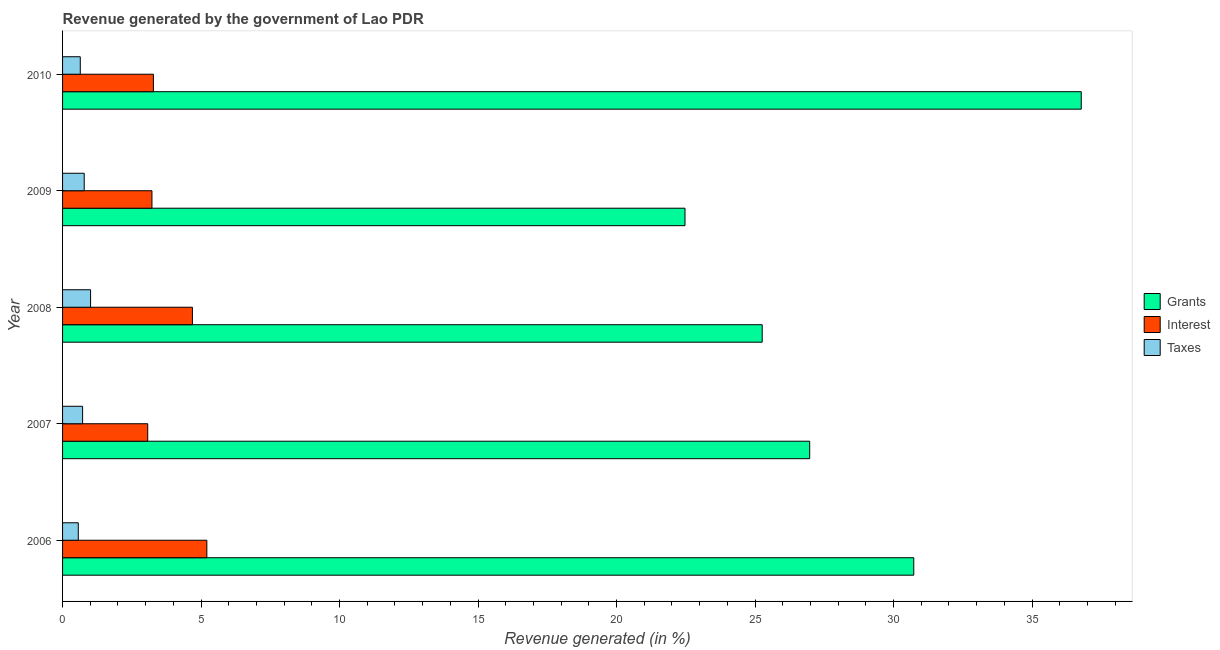How many different coloured bars are there?
Your answer should be very brief. 3. How many bars are there on the 2nd tick from the bottom?
Offer a terse response. 3. What is the percentage of revenue generated by taxes in 2008?
Ensure brevity in your answer.  1.01. Across all years, what is the maximum percentage of revenue generated by interest?
Offer a very short reply. 5.21. Across all years, what is the minimum percentage of revenue generated by interest?
Make the answer very short. 3.07. In which year was the percentage of revenue generated by interest maximum?
Ensure brevity in your answer.  2006. What is the total percentage of revenue generated by interest in the graph?
Offer a terse response. 19.48. What is the difference between the percentage of revenue generated by grants in 2009 and that in 2010?
Provide a succinct answer. -14.3. What is the difference between the percentage of revenue generated by interest in 2010 and the percentage of revenue generated by grants in 2007?
Offer a terse response. -23.69. What is the average percentage of revenue generated by grants per year?
Ensure brevity in your answer.  28.44. In the year 2009, what is the difference between the percentage of revenue generated by taxes and percentage of revenue generated by interest?
Your response must be concise. -2.44. What is the ratio of the percentage of revenue generated by grants in 2008 to that in 2010?
Ensure brevity in your answer.  0.69. Is the difference between the percentage of revenue generated by interest in 2007 and 2009 greater than the difference between the percentage of revenue generated by grants in 2007 and 2009?
Offer a terse response. No. What is the difference between the highest and the second highest percentage of revenue generated by interest?
Offer a very short reply. 0.52. What is the difference between the highest and the lowest percentage of revenue generated by taxes?
Your response must be concise. 0.44. Is the sum of the percentage of revenue generated by interest in 2006 and 2007 greater than the maximum percentage of revenue generated by grants across all years?
Provide a succinct answer. No. What does the 3rd bar from the top in 2006 represents?
Provide a short and direct response. Grants. What does the 2nd bar from the bottom in 2009 represents?
Offer a very short reply. Interest. Is it the case that in every year, the sum of the percentage of revenue generated by grants and percentage of revenue generated by interest is greater than the percentage of revenue generated by taxes?
Your answer should be compact. Yes. Are all the bars in the graph horizontal?
Give a very brief answer. Yes. How many years are there in the graph?
Offer a very short reply. 5. Are the values on the major ticks of X-axis written in scientific E-notation?
Make the answer very short. No. How are the legend labels stacked?
Give a very brief answer. Vertical. What is the title of the graph?
Make the answer very short. Revenue generated by the government of Lao PDR. Does "Primary education" appear as one of the legend labels in the graph?
Your answer should be very brief. No. What is the label or title of the X-axis?
Your answer should be compact. Revenue generated (in %). What is the Revenue generated (in %) of Grants in 2006?
Your answer should be compact. 30.73. What is the Revenue generated (in %) in Interest in 2006?
Your answer should be very brief. 5.21. What is the Revenue generated (in %) in Taxes in 2006?
Ensure brevity in your answer.  0.57. What is the Revenue generated (in %) in Grants in 2007?
Offer a very short reply. 26.97. What is the Revenue generated (in %) in Interest in 2007?
Provide a succinct answer. 3.07. What is the Revenue generated (in %) in Taxes in 2007?
Keep it short and to the point. 0.72. What is the Revenue generated (in %) in Grants in 2008?
Your answer should be compact. 25.26. What is the Revenue generated (in %) in Interest in 2008?
Your answer should be very brief. 4.69. What is the Revenue generated (in %) of Taxes in 2008?
Provide a short and direct response. 1.01. What is the Revenue generated (in %) of Grants in 2009?
Offer a terse response. 22.47. What is the Revenue generated (in %) in Interest in 2009?
Offer a terse response. 3.23. What is the Revenue generated (in %) of Taxes in 2009?
Your answer should be very brief. 0.78. What is the Revenue generated (in %) in Grants in 2010?
Your answer should be compact. 36.78. What is the Revenue generated (in %) of Interest in 2010?
Offer a terse response. 3.28. What is the Revenue generated (in %) in Taxes in 2010?
Make the answer very short. 0.64. Across all years, what is the maximum Revenue generated (in %) in Grants?
Ensure brevity in your answer.  36.78. Across all years, what is the maximum Revenue generated (in %) of Interest?
Provide a succinct answer. 5.21. Across all years, what is the maximum Revenue generated (in %) in Taxes?
Your answer should be very brief. 1.01. Across all years, what is the minimum Revenue generated (in %) in Grants?
Your answer should be compact. 22.47. Across all years, what is the minimum Revenue generated (in %) of Interest?
Offer a terse response. 3.07. Across all years, what is the minimum Revenue generated (in %) of Taxes?
Keep it short and to the point. 0.57. What is the total Revenue generated (in %) in Grants in the graph?
Ensure brevity in your answer.  142.21. What is the total Revenue generated (in %) in Interest in the graph?
Ensure brevity in your answer.  19.48. What is the total Revenue generated (in %) of Taxes in the graph?
Keep it short and to the point. 3.72. What is the difference between the Revenue generated (in %) of Grants in 2006 and that in 2007?
Your answer should be compact. 3.76. What is the difference between the Revenue generated (in %) in Interest in 2006 and that in 2007?
Make the answer very short. 2.13. What is the difference between the Revenue generated (in %) in Taxes in 2006 and that in 2007?
Offer a very short reply. -0.16. What is the difference between the Revenue generated (in %) in Grants in 2006 and that in 2008?
Your answer should be very brief. 5.47. What is the difference between the Revenue generated (in %) of Interest in 2006 and that in 2008?
Your answer should be compact. 0.52. What is the difference between the Revenue generated (in %) in Taxes in 2006 and that in 2008?
Offer a terse response. -0.44. What is the difference between the Revenue generated (in %) in Grants in 2006 and that in 2009?
Provide a short and direct response. 8.26. What is the difference between the Revenue generated (in %) of Interest in 2006 and that in 2009?
Keep it short and to the point. 1.98. What is the difference between the Revenue generated (in %) of Taxes in 2006 and that in 2009?
Your response must be concise. -0.21. What is the difference between the Revenue generated (in %) in Grants in 2006 and that in 2010?
Offer a terse response. -6.05. What is the difference between the Revenue generated (in %) of Interest in 2006 and that in 2010?
Offer a terse response. 1.93. What is the difference between the Revenue generated (in %) of Taxes in 2006 and that in 2010?
Provide a short and direct response. -0.07. What is the difference between the Revenue generated (in %) in Grants in 2007 and that in 2008?
Give a very brief answer. 1.71. What is the difference between the Revenue generated (in %) of Interest in 2007 and that in 2008?
Your response must be concise. -1.61. What is the difference between the Revenue generated (in %) in Taxes in 2007 and that in 2008?
Your response must be concise. -0.29. What is the difference between the Revenue generated (in %) in Grants in 2007 and that in 2009?
Your answer should be very brief. 4.5. What is the difference between the Revenue generated (in %) of Interest in 2007 and that in 2009?
Provide a short and direct response. -0.15. What is the difference between the Revenue generated (in %) of Taxes in 2007 and that in 2009?
Give a very brief answer. -0.06. What is the difference between the Revenue generated (in %) of Grants in 2007 and that in 2010?
Ensure brevity in your answer.  -9.8. What is the difference between the Revenue generated (in %) in Interest in 2007 and that in 2010?
Offer a very short reply. -0.21. What is the difference between the Revenue generated (in %) of Taxes in 2007 and that in 2010?
Your answer should be very brief. 0.08. What is the difference between the Revenue generated (in %) of Grants in 2008 and that in 2009?
Ensure brevity in your answer.  2.79. What is the difference between the Revenue generated (in %) of Interest in 2008 and that in 2009?
Offer a very short reply. 1.46. What is the difference between the Revenue generated (in %) in Taxes in 2008 and that in 2009?
Provide a succinct answer. 0.23. What is the difference between the Revenue generated (in %) of Grants in 2008 and that in 2010?
Provide a short and direct response. -11.52. What is the difference between the Revenue generated (in %) of Interest in 2008 and that in 2010?
Provide a short and direct response. 1.41. What is the difference between the Revenue generated (in %) of Taxes in 2008 and that in 2010?
Your answer should be compact. 0.37. What is the difference between the Revenue generated (in %) of Grants in 2009 and that in 2010?
Provide a short and direct response. -14.31. What is the difference between the Revenue generated (in %) in Interest in 2009 and that in 2010?
Ensure brevity in your answer.  -0.05. What is the difference between the Revenue generated (in %) in Taxes in 2009 and that in 2010?
Provide a short and direct response. 0.14. What is the difference between the Revenue generated (in %) in Grants in 2006 and the Revenue generated (in %) in Interest in 2007?
Offer a very short reply. 27.66. What is the difference between the Revenue generated (in %) in Grants in 2006 and the Revenue generated (in %) in Taxes in 2007?
Provide a short and direct response. 30.01. What is the difference between the Revenue generated (in %) in Interest in 2006 and the Revenue generated (in %) in Taxes in 2007?
Keep it short and to the point. 4.49. What is the difference between the Revenue generated (in %) of Grants in 2006 and the Revenue generated (in %) of Interest in 2008?
Make the answer very short. 26.04. What is the difference between the Revenue generated (in %) of Grants in 2006 and the Revenue generated (in %) of Taxes in 2008?
Your answer should be very brief. 29.72. What is the difference between the Revenue generated (in %) in Interest in 2006 and the Revenue generated (in %) in Taxes in 2008?
Your response must be concise. 4.2. What is the difference between the Revenue generated (in %) of Grants in 2006 and the Revenue generated (in %) of Interest in 2009?
Offer a terse response. 27.5. What is the difference between the Revenue generated (in %) in Grants in 2006 and the Revenue generated (in %) in Taxes in 2009?
Give a very brief answer. 29.95. What is the difference between the Revenue generated (in %) in Interest in 2006 and the Revenue generated (in %) in Taxes in 2009?
Your answer should be compact. 4.43. What is the difference between the Revenue generated (in %) of Grants in 2006 and the Revenue generated (in %) of Interest in 2010?
Your answer should be compact. 27.45. What is the difference between the Revenue generated (in %) in Grants in 2006 and the Revenue generated (in %) in Taxes in 2010?
Ensure brevity in your answer.  30.09. What is the difference between the Revenue generated (in %) of Interest in 2006 and the Revenue generated (in %) of Taxes in 2010?
Your answer should be compact. 4.57. What is the difference between the Revenue generated (in %) of Grants in 2007 and the Revenue generated (in %) of Interest in 2008?
Ensure brevity in your answer.  22.28. What is the difference between the Revenue generated (in %) in Grants in 2007 and the Revenue generated (in %) in Taxes in 2008?
Your answer should be compact. 25.96. What is the difference between the Revenue generated (in %) of Interest in 2007 and the Revenue generated (in %) of Taxes in 2008?
Provide a short and direct response. 2.06. What is the difference between the Revenue generated (in %) in Grants in 2007 and the Revenue generated (in %) in Interest in 2009?
Your answer should be compact. 23.75. What is the difference between the Revenue generated (in %) of Grants in 2007 and the Revenue generated (in %) of Taxes in 2009?
Offer a very short reply. 26.19. What is the difference between the Revenue generated (in %) of Interest in 2007 and the Revenue generated (in %) of Taxes in 2009?
Ensure brevity in your answer.  2.29. What is the difference between the Revenue generated (in %) in Grants in 2007 and the Revenue generated (in %) in Interest in 2010?
Your response must be concise. 23.69. What is the difference between the Revenue generated (in %) of Grants in 2007 and the Revenue generated (in %) of Taxes in 2010?
Your answer should be very brief. 26.33. What is the difference between the Revenue generated (in %) of Interest in 2007 and the Revenue generated (in %) of Taxes in 2010?
Make the answer very short. 2.43. What is the difference between the Revenue generated (in %) of Grants in 2008 and the Revenue generated (in %) of Interest in 2009?
Your response must be concise. 22.03. What is the difference between the Revenue generated (in %) of Grants in 2008 and the Revenue generated (in %) of Taxes in 2009?
Your answer should be compact. 24.48. What is the difference between the Revenue generated (in %) in Interest in 2008 and the Revenue generated (in %) in Taxes in 2009?
Keep it short and to the point. 3.91. What is the difference between the Revenue generated (in %) of Grants in 2008 and the Revenue generated (in %) of Interest in 2010?
Your response must be concise. 21.98. What is the difference between the Revenue generated (in %) of Grants in 2008 and the Revenue generated (in %) of Taxes in 2010?
Provide a succinct answer. 24.62. What is the difference between the Revenue generated (in %) in Interest in 2008 and the Revenue generated (in %) in Taxes in 2010?
Give a very brief answer. 4.05. What is the difference between the Revenue generated (in %) of Grants in 2009 and the Revenue generated (in %) of Interest in 2010?
Make the answer very short. 19.19. What is the difference between the Revenue generated (in %) of Grants in 2009 and the Revenue generated (in %) of Taxes in 2010?
Ensure brevity in your answer.  21.83. What is the difference between the Revenue generated (in %) of Interest in 2009 and the Revenue generated (in %) of Taxes in 2010?
Your response must be concise. 2.59. What is the average Revenue generated (in %) in Grants per year?
Give a very brief answer. 28.44. What is the average Revenue generated (in %) of Interest per year?
Your answer should be very brief. 3.9. What is the average Revenue generated (in %) of Taxes per year?
Keep it short and to the point. 0.74. In the year 2006, what is the difference between the Revenue generated (in %) of Grants and Revenue generated (in %) of Interest?
Provide a succinct answer. 25.52. In the year 2006, what is the difference between the Revenue generated (in %) of Grants and Revenue generated (in %) of Taxes?
Keep it short and to the point. 30.16. In the year 2006, what is the difference between the Revenue generated (in %) in Interest and Revenue generated (in %) in Taxes?
Offer a terse response. 4.64. In the year 2007, what is the difference between the Revenue generated (in %) of Grants and Revenue generated (in %) of Interest?
Make the answer very short. 23.9. In the year 2007, what is the difference between the Revenue generated (in %) of Grants and Revenue generated (in %) of Taxes?
Make the answer very short. 26.25. In the year 2007, what is the difference between the Revenue generated (in %) in Interest and Revenue generated (in %) in Taxes?
Provide a succinct answer. 2.35. In the year 2008, what is the difference between the Revenue generated (in %) in Grants and Revenue generated (in %) in Interest?
Give a very brief answer. 20.57. In the year 2008, what is the difference between the Revenue generated (in %) in Grants and Revenue generated (in %) in Taxes?
Make the answer very short. 24.25. In the year 2008, what is the difference between the Revenue generated (in %) of Interest and Revenue generated (in %) of Taxes?
Your answer should be very brief. 3.68. In the year 2009, what is the difference between the Revenue generated (in %) in Grants and Revenue generated (in %) in Interest?
Offer a very short reply. 19.24. In the year 2009, what is the difference between the Revenue generated (in %) in Grants and Revenue generated (in %) in Taxes?
Your answer should be very brief. 21.69. In the year 2009, what is the difference between the Revenue generated (in %) of Interest and Revenue generated (in %) of Taxes?
Provide a short and direct response. 2.45. In the year 2010, what is the difference between the Revenue generated (in %) in Grants and Revenue generated (in %) in Interest?
Ensure brevity in your answer.  33.5. In the year 2010, what is the difference between the Revenue generated (in %) of Grants and Revenue generated (in %) of Taxes?
Provide a short and direct response. 36.14. In the year 2010, what is the difference between the Revenue generated (in %) of Interest and Revenue generated (in %) of Taxes?
Your answer should be very brief. 2.64. What is the ratio of the Revenue generated (in %) in Grants in 2006 to that in 2007?
Give a very brief answer. 1.14. What is the ratio of the Revenue generated (in %) in Interest in 2006 to that in 2007?
Provide a succinct answer. 1.69. What is the ratio of the Revenue generated (in %) in Taxes in 2006 to that in 2007?
Give a very brief answer. 0.78. What is the ratio of the Revenue generated (in %) in Grants in 2006 to that in 2008?
Give a very brief answer. 1.22. What is the ratio of the Revenue generated (in %) in Interest in 2006 to that in 2008?
Ensure brevity in your answer.  1.11. What is the ratio of the Revenue generated (in %) of Taxes in 2006 to that in 2008?
Make the answer very short. 0.56. What is the ratio of the Revenue generated (in %) of Grants in 2006 to that in 2009?
Your response must be concise. 1.37. What is the ratio of the Revenue generated (in %) in Interest in 2006 to that in 2009?
Your answer should be compact. 1.61. What is the ratio of the Revenue generated (in %) of Taxes in 2006 to that in 2009?
Give a very brief answer. 0.73. What is the ratio of the Revenue generated (in %) of Grants in 2006 to that in 2010?
Give a very brief answer. 0.84. What is the ratio of the Revenue generated (in %) of Interest in 2006 to that in 2010?
Provide a succinct answer. 1.59. What is the ratio of the Revenue generated (in %) of Taxes in 2006 to that in 2010?
Provide a short and direct response. 0.89. What is the ratio of the Revenue generated (in %) of Grants in 2007 to that in 2008?
Give a very brief answer. 1.07. What is the ratio of the Revenue generated (in %) in Interest in 2007 to that in 2008?
Give a very brief answer. 0.66. What is the ratio of the Revenue generated (in %) of Taxes in 2007 to that in 2008?
Offer a terse response. 0.72. What is the ratio of the Revenue generated (in %) in Grants in 2007 to that in 2009?
Your answer should be compact. 1.2. What is the ratio of the Revenue generated (in %) of Interest in 2007 to that in 2009?
Make the answer very short. 0.95. What is the ratio of the Revenue generated (in %) of Taxes in 2007 to that in 2009?
Provide a short and direct response. 0.93. What is the ratio of the Revenue generated (in %) of Grants in 2007 to that in 2010?
Make the answer very short. 0.73. What is the ratio of the Revenue generated (in %) in Interest in 2007 to that in 2010?
Offer a terse response. 0.94. What is the ratio of the Revenue generated (in %) of Taxes in 2007 to that in 2010?
Offer a very short reply. 1.13. What is the ratio of the Revenue generated (in %) in Grants in 2008 to that in 2009?
Your answer should be compact. 1.12. What is the ratio of the Revenue generated (in %) of Interest in 2008 to that in 2009?
Offer a terse response. 1.45. What is the ratio of the Revenue generated (in %) in Taxes in 2008 to that in 2009?
Ensure brevity in your answer.  1.29. What is the ratio of the Revenue generated (in %) in Grants in 2008 to that in 2010?
Make the answer very short. 0.69. What is the ratio of the Revenue generated (in %) in Interest in 2008 to that in 2010?
Ensure brevity in your answer.  1.43. What is the ratio of the Revenue generated (in %) in Taxes in 2008 to that in 2010?
Your answer should be very brief. 1.58. What is the ratio of the Revenue generated (in %) in Grants in 2009 to that in 2010?
Provide a succinct answer. 0.61. What is the ratio of the Revenue generated (in %) in Interest in 2009 to that in 2010?
Keep it short and to the point. 0.98. What is the ratio of the Revenue generated (in %) in Taxes in 2009 to that in 2010?
Your response must be concise. 1.22. What is the difference between the highest and the second highest Revenue generated (in %) of Grants?
Your answer should be very brief. 6.05. What is the difference between the highest and the second highest Revenue generated (in %) in Interest?
Keep it short and to the point. 0.52. What is the difference between the highest and the second highest Revenue generated (in %) in Taxes?
Give a very brief answer. 0.23. What is the difference between the highest and the lowest Revenue generated (in %) in Grants?
Your answer should be compact. 14.31. What is the difference between the highest and the lowest Revenue generated (in %) of Interest?
Provide a short and direct response. 2.13. What is the difference between the highest and the lowest Revenue generated (in %) of Taxes?
Give a very brief answer. 0.44. 